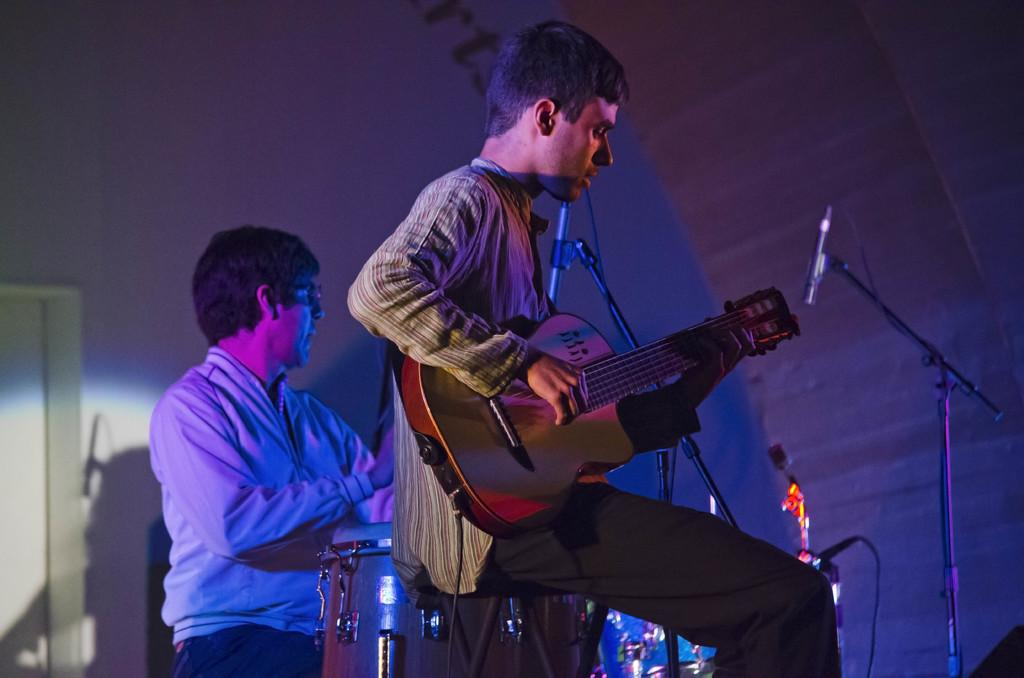What is the man in the image doing? The man is playing a guitar in the image. How many people are in the image? There is one person in the image. What other musical instrument can be seen in the image? There is a drum in the image. What device is present for amplifying sound? There is a microphone (mic) in the image. Can you tell me how many owls are sitting on the guitar in the image? There are no owls present in the image; it features a man playing a guitar, a drum, and a microphone. 